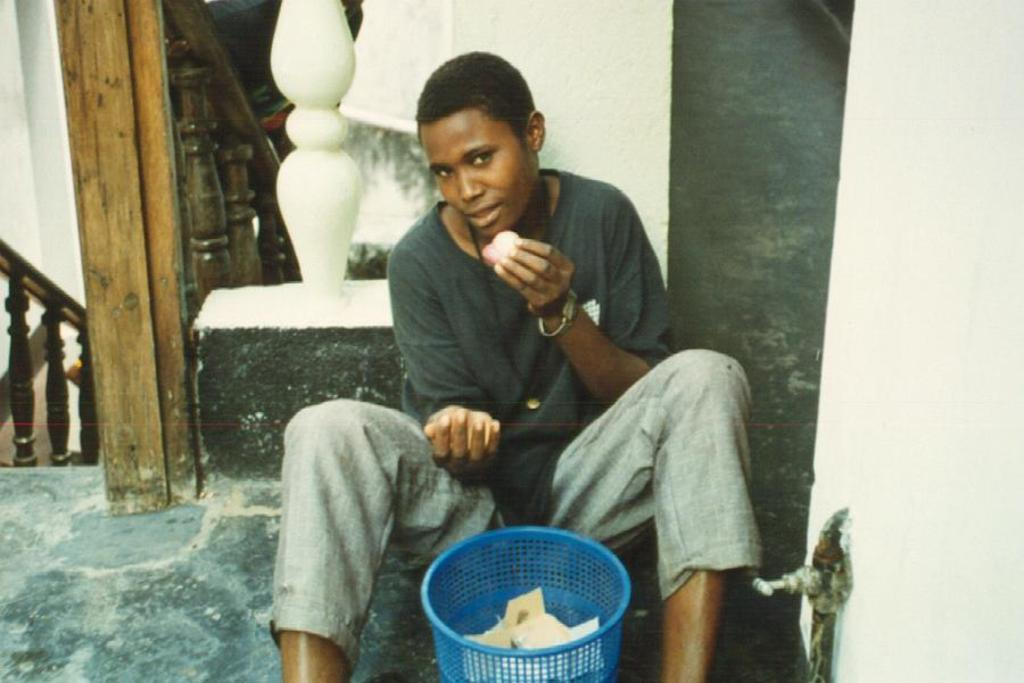What is the person in the image doing? There is a person sitting on the floor in the image. What is the person holding? The person is holding an object. What can be seen in the background of the image? There is a staircase in the background of the image. What is the purpose of the dustbin in the image? The dustbin contains papers, suggesting it is for disposing of unwanted or used papers. What type of crayon is the person using to draw on the wall in the image? There is no crayon or drawing on the wall present in the image. How many apples are on the staircase in the image? There are no apples visible on the staircase in the image. 